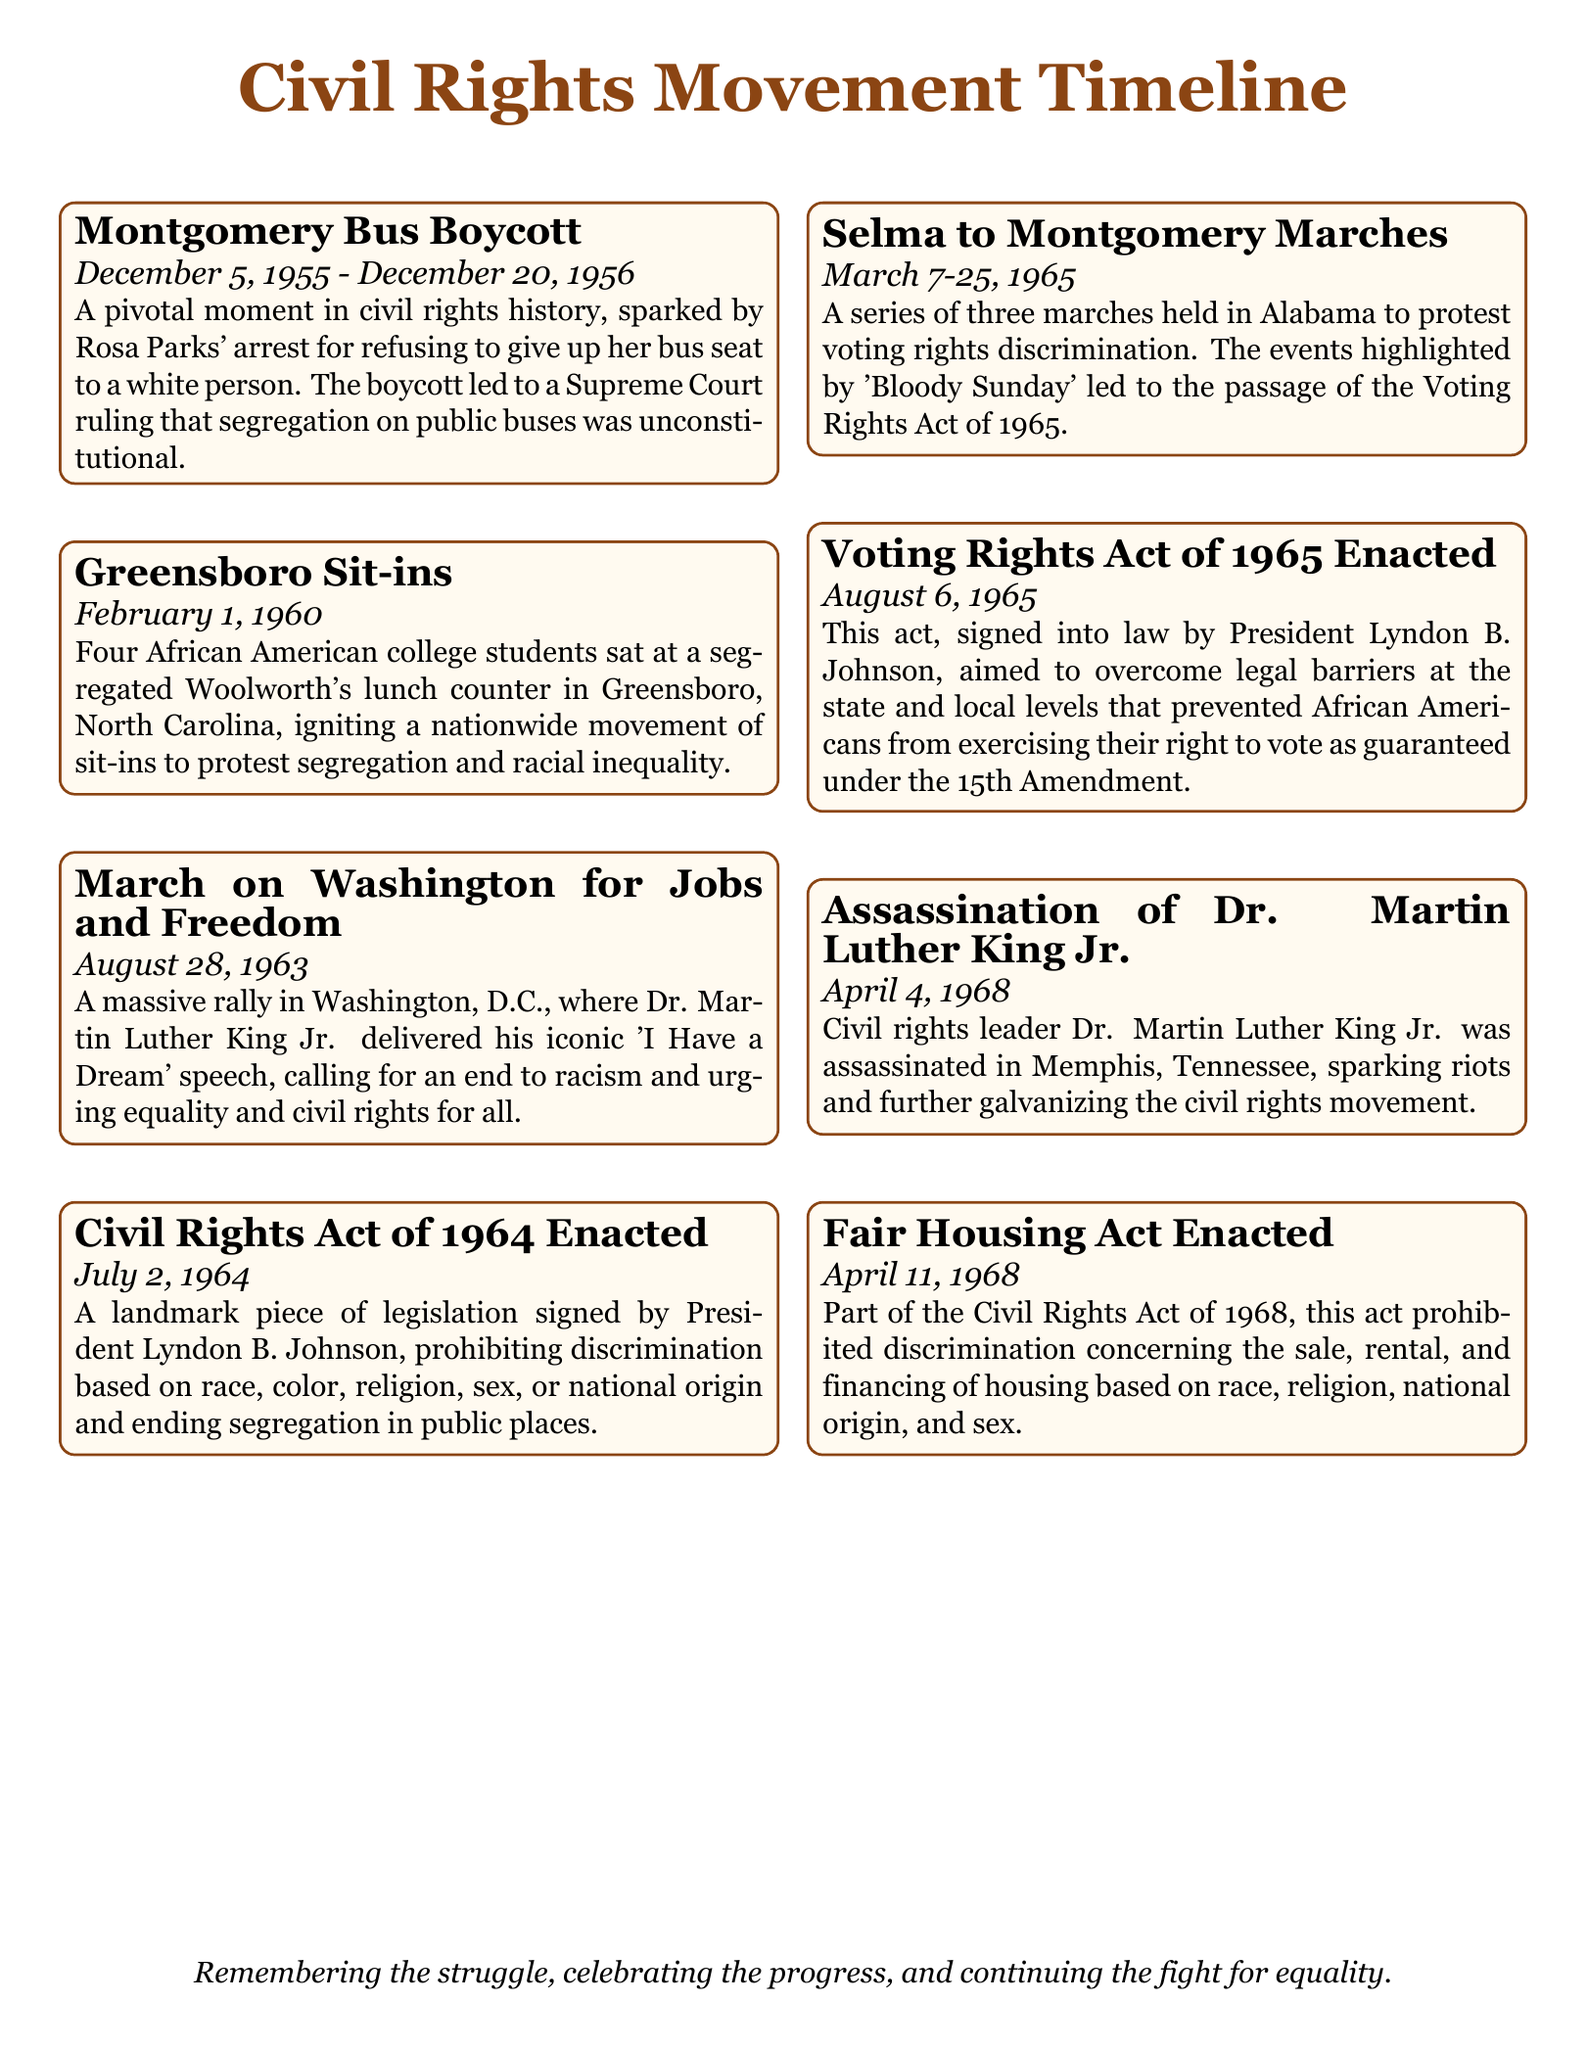What event started on December 5, 1955? The event that started on this date was the Montgomery Bus Boycott, which was a pivotal moment in civil rights history.
Answer: Montgomery Bus Boycott What significant speech did Dr. Martin Luther King Jr. deliver on August 28, 1963? Dr. Martin Luther King Jr. delivered the "I Have a Dream" speech during the March on Washington for Jobs and Freedom.
Answer: I Have a Dream Which landmark legislation was enacted on July 2, 1964? This legislation was the Civil Rights Act of 1964, prohibiting discrimination based on various factors.
Answer: Civil Rights Act of 1964 What event is associated with "Bloody Sunday"? The Selma to Montgomery Marches are associated with "Bloody Sunday," which highlighted voting rights discrimination.
Answer: Selma to Montgomery Marches What was the outcome of the Montgomery Bus Boycott? The outcome was a Supreme Court ruling that segregation on public buses was unconstitutional.
Answer: Supreme Court ruling How many marches were held in the Selma to Montgomery events? There were three marches held during the Selma to Montgomery events.
Answer: Three marches What year did the Voting Rights Act become law? The Voting Rights Act was enacted on August 6, 1965.
Answer: 1965 Which housing act was enacted on April 11, 1968? The Fair Housing Act, part of the Civil Rights Act of 1968, was enacted on this date.
Answer: Fair Housing Act What event occurred on April 4, 1968? The assassination of Dr. Martin Luther King Jr. occurred on this date.
Answer: Assassination of Dr. Martin Luther King Jr What movement did the Greensboro Sit-ins spark? The Greensboro Sit-ins sparked a nationwide movement of sit-ins to protest segregation and racial inequality.
Answer: Nationwide movement of sit-ins 